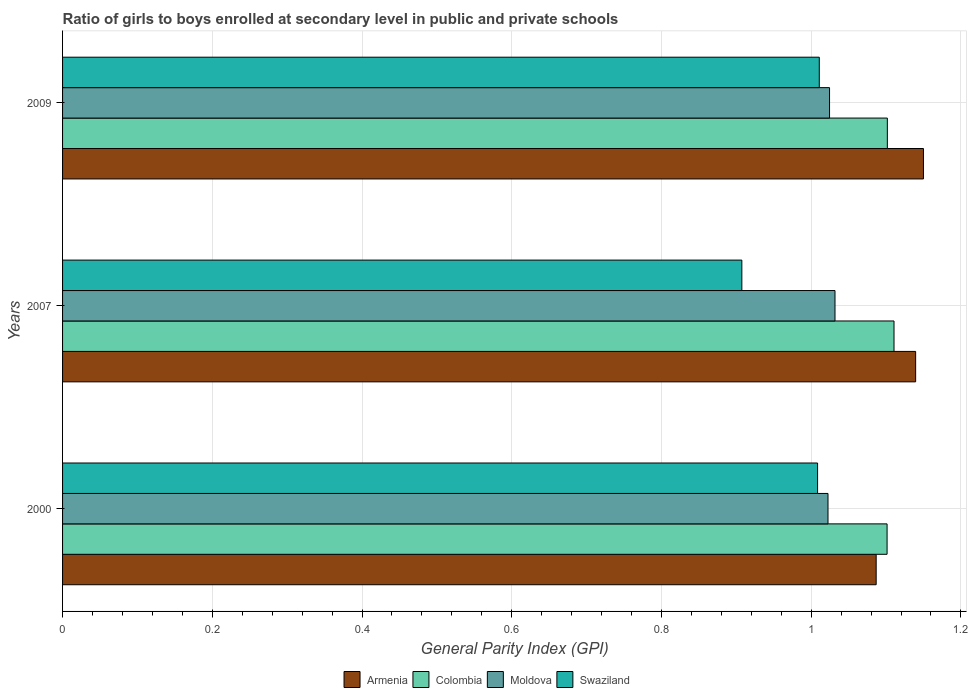Are the number of bars per tick equal to the number of legend labels?
Offer a very short reply. Yes. Are the number of bars on each tick of the Y-axis equal?
Offer a terse response. Yes. How many bars are there on the 1st tick from the top?
Your answer should be compact. 4. What is the label of the 1st group of bars from the top?
Your response must be concise. 2009. In how many cases, is the number of bars for a given year not equal to the number of legend labels?
Give a very brief answer. 0. What is the general parity index in Colombia in 2009?
Your answer should be compact. 1.1. Across all years, what is the maximum general parity index in Colombia?
Your answer should be very brief. 1.11. Across all years, what is the minimum general parity index in Moldova?
Offer a very short reply. 1.02. In which year was the general parity index in Colombia minimum?
Make the answer very short. 2000. What is the total general parity index in Armenia in the graph?
Your answer should be compact. 3.38. What is the difference between the general parity index in Colombia in 2007 and that in 2009?
Your answer should be very brief. 0.01. What is the difference between the general parity index in Colombia in 2009 and the general parity index in Swaziland in 2007?
Give a very brief answer. 0.19. What is the average general parity index in Colombia per year?
Your answer should be very brief. 1.1. In the year 2007, what is the difference between the general parity index in Moldova and general parity index in Armenia?
Provide a succinct answer. -0.11. What is the ratio of the general parity index in Moldova in 2000 to that in 2009?
Keep it short and to the point. 1. Is the general parity index in Swaziland in 2000 less than that in 2009?
Make the answer very short. Yes. Is the difference between the general parity index in Moldova in 2000 and 2007 greater than the difference between the general parity index in Armenia in 2000 and 2007?
Give a very brief answer. Yes. What is the difference between the highest and the second highest general parity index in Armenia?
Make the answer very short. 0.01. What is the difference between the highest and the lowest general parity index in Swaziland?
Provide a succinct answer. 0.1. Is the sum of the general parity index in Colombia in 2007 and 2009 greater than the maximum general parity index in Swaziland across all years?
Ensure brevity in your answer.  Yes. What does the 2nd bar from the top in 2000 represents?
Your answer should be very brief. Moldova. What does the 2nd bar from the bottom in 2007 represents?
Ensure brevity in your answer.  Colombia. Are all the bars in the graph horizontal?
Your answer should be compact. Yes. What is the difference between two consecutive major ticks on the X-axis?
Offer a terse response. 0.2. Where does the legend appear in the graph?
Ensure brevity in your answer.  Bottom center. How many legend labels are there?
Provide a short and direct response. 4. How are the legend labels stacked?
Your response must be concise. Horizontal. What is the title of the graph?
Provide a short and direct response. Ratio of girls to boys enrolled at secondary level in public and private schools. What is the label or title of the X-axis?
Provide a short and direct response. General Parity Index (GPI). What is the label or title of the Y-axis?
Provide a short and direct response. Years. What is the General Parity Index (GPI) in Armenia in 2000?
Offer a very short reply. 1.09. What is the General Parity Index (GPI) of Colombia in 2000?
Your answer should be compact. 1.1. What is the General Parity Index (GPI) of Moldova in 2000?
Keep it short and to the point. 1.02. What is the General Parity Index (GPI) in Swaziland in 2000?
Provide a short and direct response. 1.01. What is the General Parity Index (GPI) of Armenia in 2007?
Your response must be concise. 1.14. What is the General Parity Index (GPI) of Colombia in 2007?
Offer a terse response. 1.11. What is the General Parity Index (GPI) in Moldova in 2007?
Offer a very short reply. 1.03. What is the General Parity Index (GPI) in Swaziland in 2007?
Keep it short and to the point. 0.91. What is the General Parity Index (GPI) of Armenia in 2009?
Ensure brevity in your answer.  1.15. What is the General Parity Index (GPI) of Colombia in 2009?
Make the answer very short. 1.1. What is the General Parity Index (GPI) of Moldova in 2009?
Offer a very short reply. 1.02. What is the General Parity Index (GPI) of Swaziland in 2009?
Give a very brief answer. 1.01. Across all years, what is the maximum General Parity Index (GPI) of Armenia?
Offer a very short reply. 1.15. Across all years, what is the maximum General Parity Index (GPI) of Colombia?
Offer a terse response. 1.11. Across all years, what is the maximum General Parity Index (GPI) in Moldova?
Provide a short and direct response. 1.03. Across all years, what is the maximum General Parity Index (GPI) in Swaziland?
Your answer should be compact. 1.01. Across all years, what is the minimum General Parity Index (GPI) of Armenia?
Ensure brevity in your answer.  1.09. Across all years, what is the minimum General Parity Index (GPI) in Colombia?
Offer a terse response. 1.1. Across all years, what is the minimum General Parity Index (GPI) of Moldova?
Ensure brevity in your answer.  1.02. Across all years, what is the minimum General Parity Index (GPI) of Swaziland?
Provide a short and direct response. 0.91. What is the total General Parity Index (GPI) of Armenia in the graph?
Provide a short and direct response. 3.38. What is the total General Parity Index (GPI) of Colombia in the graph?
Offer a terse response. 3.31. What is the total General Parity Index (GPI) in Moldova in the graph?
Your answer should be very brief. 3.08. What is the total General Parity Index (GPI) in Swaziland in the graph?
Your response must be concise. 2.93. What is the difference between the General Parity Index (GPI) in Armenia in 2000 and that in 2007?
Your answer should be very brief. -0.05. What is the difference between the General Parity Index (GPI) in Colombia in 2000 and that in 2007?
Offer a terse response. -0.01. What is the difference between the General Parity Index (GPI) of Moldova in 2000 and that in 2007?
Your answer should be very brief. -0.01. What is the difference between the General Parity Index (GPI) in Swaziland in 2000 and that in 2007?
Give a very brief answer. 0.1. What is the difference between the General Parity Index (GPI) in Armenia in 2000 and that in 2009?
Your answer should be compact. -0.06. What is the difference between the General Parity Index (GPI) of Colombia in 2000 and that in 2009?
Keep it short and to the point. -0. What is the difference between the General Parity Index (GPI) in Moldova in 2000 and that in 2009?
Give a very brief answer. -0. What is the difference between the General Parity Index (GPI) of Swaziland in 2000 and that in 2009?
Your response must be concise. -0. What is the difference between the General Parity Index (GPI) of Armenia in 2007 and that in 2009?
Keep it short and to the point. -0.01. What is the difference between the General Parity Index (GPI) of Colombia in 2007 and that in 2009?
Give a very brief answer. 0.01. What is the difference between the General Parity Index (GPI) of Moldova in 2007 and that in 2009?
Provide a short and direct response. 0.01. What is the difference between the General Parity Index (GPI) in Swaziland in 2007 and that in 2009?
Give a very brief answer. -0.1. What is the difference between the General Parity Index (GPI) in Armenia in 2000 and the General Parity Index (GPI) in Colombia in 2007?
Provide a succinct answer. -0.02. What is the difference between the General Parity Index (GPI) in Armenia in 2000 and the General Parity Index (GPI) in Moldova in 2007?
Your response must be concise. 0.06. What is the difference between the General Parity Index (GPI) of Armenia in 2000 and the General Parity Index (GPI) of Swaziland in 2007?
Provide a short and direct response. 0.18. What is the difference between the General Parity Index (GPI) in Colombia in 2000 and the General Parity Index (GPI) in Moldova in 2007?
Provide a short and direct response. 0.07. What is the difference between the General Parity Index (GPI) of Colombia in 2000 and the General Parity Index (GPI) of Swaziland in 2007?
Your answer should be compact. 0.19. What is the difference between the General Parity Index (GPI) in Moldova in 2000 and the General Parity Index (GPI) in Swaziland in 2007?
Your answer should be very brief. 0.12. What is the difference between the General Parity Index (GPI) of Armenia in 2000 and the General Parity Index (GPI) of Colombia in 2009?
Your response must be concise. -0.01. What is the difference between the General Parity Index (GPI) of Armenia in 2000 and the General Parity Index (GPI) of Moldova in 2009?
Offer a terse response. 0.06. What is the difference between the General Parity Index (GPI) of Armenia in 2000 and the General Parity Index (GPI) of Swaziland in 2009?
Your answer should be very brief. 0.08. What is the difference between the General Parity Index (GPI) of Colombia in 2000 and the General Parity Index (GPI) of Moldova in 2009?
Your answer should be compact. 0.08. What is the difference between the General Parity Index (GPI) in Colombia in 2000 and the General Parity Index (GPI) in Swaziland in 2009?
Provide a short and direct response. 0.09. What is the difference between the General Parity Index (GPI) of Moldova in 2000 and the General Parity Index (GPI) of Swaziland in 2009?
Keep it short and to the point. 0.01. What is the difference between the General Parity Index (GPI) in Armenia in 2007 and the General Parity Index (GPI) in Colombia in 2009?
Ensure brevity in your answer.  0.04. What is the difference between the General Parity Index (GPI) of Armenia in 2007 and the General Parity Index (GPI) of Moldova in 2009?
Ensure brevity in your answer.  0.12. What is the difference between the General Parity Index (GPI) of Armenia in 2007 and the General Parity Index (GPI) of Swaziland in 2009?
Provide a succinct answer. 0.13. What is the difference between the General Parity Index (GPI) in Colombia in 2007 and the General Parity Index (GPI) in Moldova in 2009?
Give a very brief answer. 0.09. What is the difference between the General Parity Index (GPI) of Colombia in 2007 and the General Parity Index (GPI) of Swaziland in 2009?
Keep it short and to the point. 0.1. What is the difference between the General Parity Index (GPI) in Moldova in 2007 and the General Parity Index (GPI) in Swaziland in 2009?
Offer a very short reply. 0.02. What is the average General Parity Index (GPI) of Armenia per year?
Provide a succinct answer. 1.13. What is the average General Parity Index (GPI) in Colombia per year?
Your response must be concise. 1.1. What is the average General Parity Index (GPI) of Moldova per year?
Provide a succinct answer. 1.03. What is the average General Parity Index (GPI) of Swaziland per year?
Your answer should be compact. 0.98. In the year 2000, what is the difference between the General Parity Index (GPI) in Armenia and General Parity Index (GPI) in Colombia?
Make the answer very short. -0.01. In the year 2000, what is the difference between the General Parity Index (GPI) in Armenia and General Parity Index (GPI) in Moldova?
Provide a succinct answer. 0.06. In the year 2000, what is the difference between the General Parity Index (GPI) of Armenia and General Parity Index (GPI) of Swaziland?
Give a very brief answer. 0.08. In the year 2000, what is the difference between the General Parity Index (GPI) of Colombia and General Parity Index (GPI) of Moldova?
Make the answer very short. 0.08. In the year 2000, what is the difference between the General Parity Index (GPI) of Colombia and General Parity Index (GPI) of Swaziland?
Provide a succinct answer. 0.09. In the year 2000, what is the difference between the General Parity Index (GPI) in Moldova and General Parity Index (GPI) in Swaziland?
Provide a short and direct response. 0.01. In the year 2007, what is the difference between the General Parity Index (GPI) in Armenia and General Parity Index (GPI) in Colombia?
Provide a short and direct response. 0.03. In the year 2007, what is the difference between the General Parity Index (GPI) of Armenia and General Parity Index (GPI) of Moldova?
Provide a short and direct response. 0.11. In the year 2007, what is the difference between the General Parity Index (GPI) in Armenia and General Parity Index (GPI) in Swaziland?
Make the answer very short. 0.23. In the year 2007, what is the difference between the General Parity Index (GPI) in Colombia and General Parity Index (GPI) in Moldova?
Offer a very short reply. 0.08. In the year 2007, what is the difference between the General Parity Index (GPI) in Colombia and General Parity Index (GPI) in Swaziland?
Keep it short and to the point. 0.2. In the year 2007, what is the difference between the General Parity Index (GPI) of Moldova and General Parity Index (GPI) of Swaziland?
Ensure brevity in your answer.  0.12. In the year 2009, what is the difference between the General Parity Index (GPI) in Armenia and General Parity Index (GPI) in Colombia?
Your answer should be very brief. 0.05. In the year 2009, what is the difference between the General Parity Index (GPI) of Armenia and General Parity Index (GPI) of Moldova?
Your answer should be compact. 0.13. In the year 2009, what is the difference between the General Parity Index (GPI) of Armenia and General Parity Index (GPI) of Swaziland?
Offer a terse response. 0.14. In the year 2009, what is the difference between the General Parity Index (GPI) of Colombia and General Parity Index (GPI) of Moldova?
Your response must be concise. 0.08. In the year 2009, what is the difference between the General Parity Index (GPI) in Colombia and General Parity Index (GPI) in Swaziland?
Ensure brevity in your answer.  0.09. In the year 2009, what is the difference between the General Parity Index (GPI) in Moldova and General Parity Index (GPI) in Swaziland?
Your answer should be compact. 0.01. What is the ratio of the General Parity Index (GPI) in Armenia in 2000 to that in 2007?
Give a very brief answer. 0.95. What is the ratio of the General Parity Index (GPI) of Colombia in 2000 to that in 2007?
Offer a terse response. 0.99. What is the ratio of the General Parity Index (GPI) in Moldova in 2000 to that in 2007?
Make the answer very short. 0.99. What is the ratio of the General Parity Index (GPI) in Swaziland in 2000 to that in 2007?
Make the answer very short. 1.11. What is the ratio of the General Parity Index (GPI) in Armenia in 2000 to that in 2009?
Your answer should be very brief. 0.95. What is the ratio of the General Parity Index (GPI) of Colombia in 2000 to that in 2009?
Make the answer very short. 1. What is the ratio of the General Parity Index (GPI) in Moldova in 2000 to that in 2009?
Give a very brief answer. 1. What is the ratio of the General Parity Index (GPI) of Armenia in 2007 to that in 2009?
Ensure brevity in your answer.  0.99. What is the ratio of the General Parity Index (GPI) in Moldova in 2007 to that in 2009?
Provide a short and direct response. 1.01. What is the ratio of the General Parity Index (GPI) in Swaziland in 2007 to that in 2009?
Provide a succinct answer. 0.9. What is the difference between the highest and the second highest General Parity Index (GPI) in Armenia?
Give a very brief answer. 0.01. What is the difference between the highest and the second highest General Parity Index (GPI) in Colombia?
Give a very brief answer. 0.01. What is the difference between the highest and the second highest General Parity Index (GPI) in Moldova?
Keep it short and to the point. 0.01. What is the difference between the highest and the second highest General Parity Index (GPI) in Swaziland?
Make the answer very short. 0. What is the difference between the highest and the lowest General Parity Index (GPI) of Armenia?
Your answer should be compact. 0.06. What is the difference between the highest and the lowest General Parity Index (GPI) of Colombia?
Your response must be concise. 0.01. What is the difference between the highest and the lowest General Parity Index (GPI) of Moldova?
Offer a terse response. 0.01. What is the difference between the highest and the lowest General Parity Index (GPI) in Swaziland?
Give a very brief answer. 0.1. 